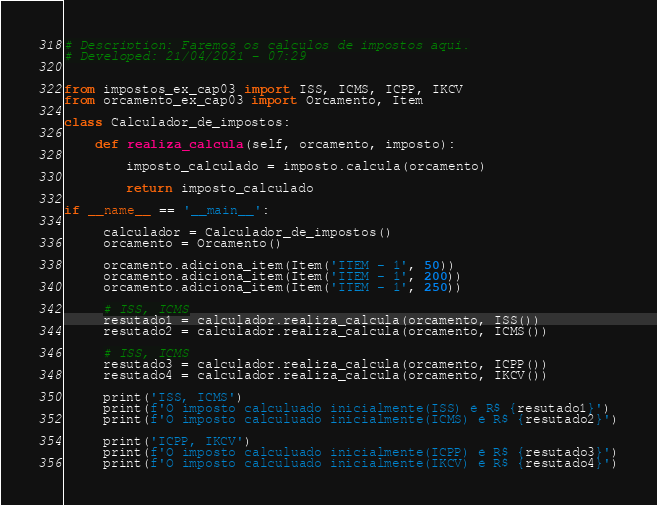Convert code to text. <code><loc_0><loc_0><loc_500><loc_500><_Python_># Description: Faremos os calculos de impostos aqui.
# Developed: 21/04/2021 - 07:29


from impostos_ex_cap03 import ISS, ICMS, ICPP, IKCV
from orcamento_ex_cap03 import Orcamento, Item

class Calculador_de_impostos:

    def realiza_calcula(self, orcamento, imposto):

        imposto_calculado = imposto.calcula(orcamento)

        return imposto_calculado

if __name__ == '__main__':

     calculador = Calculador_de_impostos()
     orcamento = Orcamento()

     orcamento.adiciona_item(Item('ITEM - 1', 50))
     orcamento.adiciona_item(Item('ITEM - 1', 200))
     orcamento.adiciona_item(Item('ITEM - 1', 250))

     # ISS, ICMS
     resutado1 = calculador.realiza_calcula(orcamento, ISS())
     resutado2 = calculador.realiza_calcula(orcamento, ICMS())

     # ISS, ICMS
     resutado3 = calculador.realiza_calcula(orcamento, ICPP())
     resutado4 = calculador.realiza_calcula(orcamento, IKCV())

     print('ISS, ICMS')
     print(f'O imposto calculuado inicialmente(ISS) é R$ {resutado1}')
     print(f'O imposto calculuado inicialmente(ICMS) é R$ {resutado2}')

     print('ICPP, IKCV')
     print(f'O imposto calculuado inicialmente(ICPP) é R$ {resutado3}')
     print(f'O imposto calculuado inicialmente(IKCV) é R$ {resutado4}')


</code> 